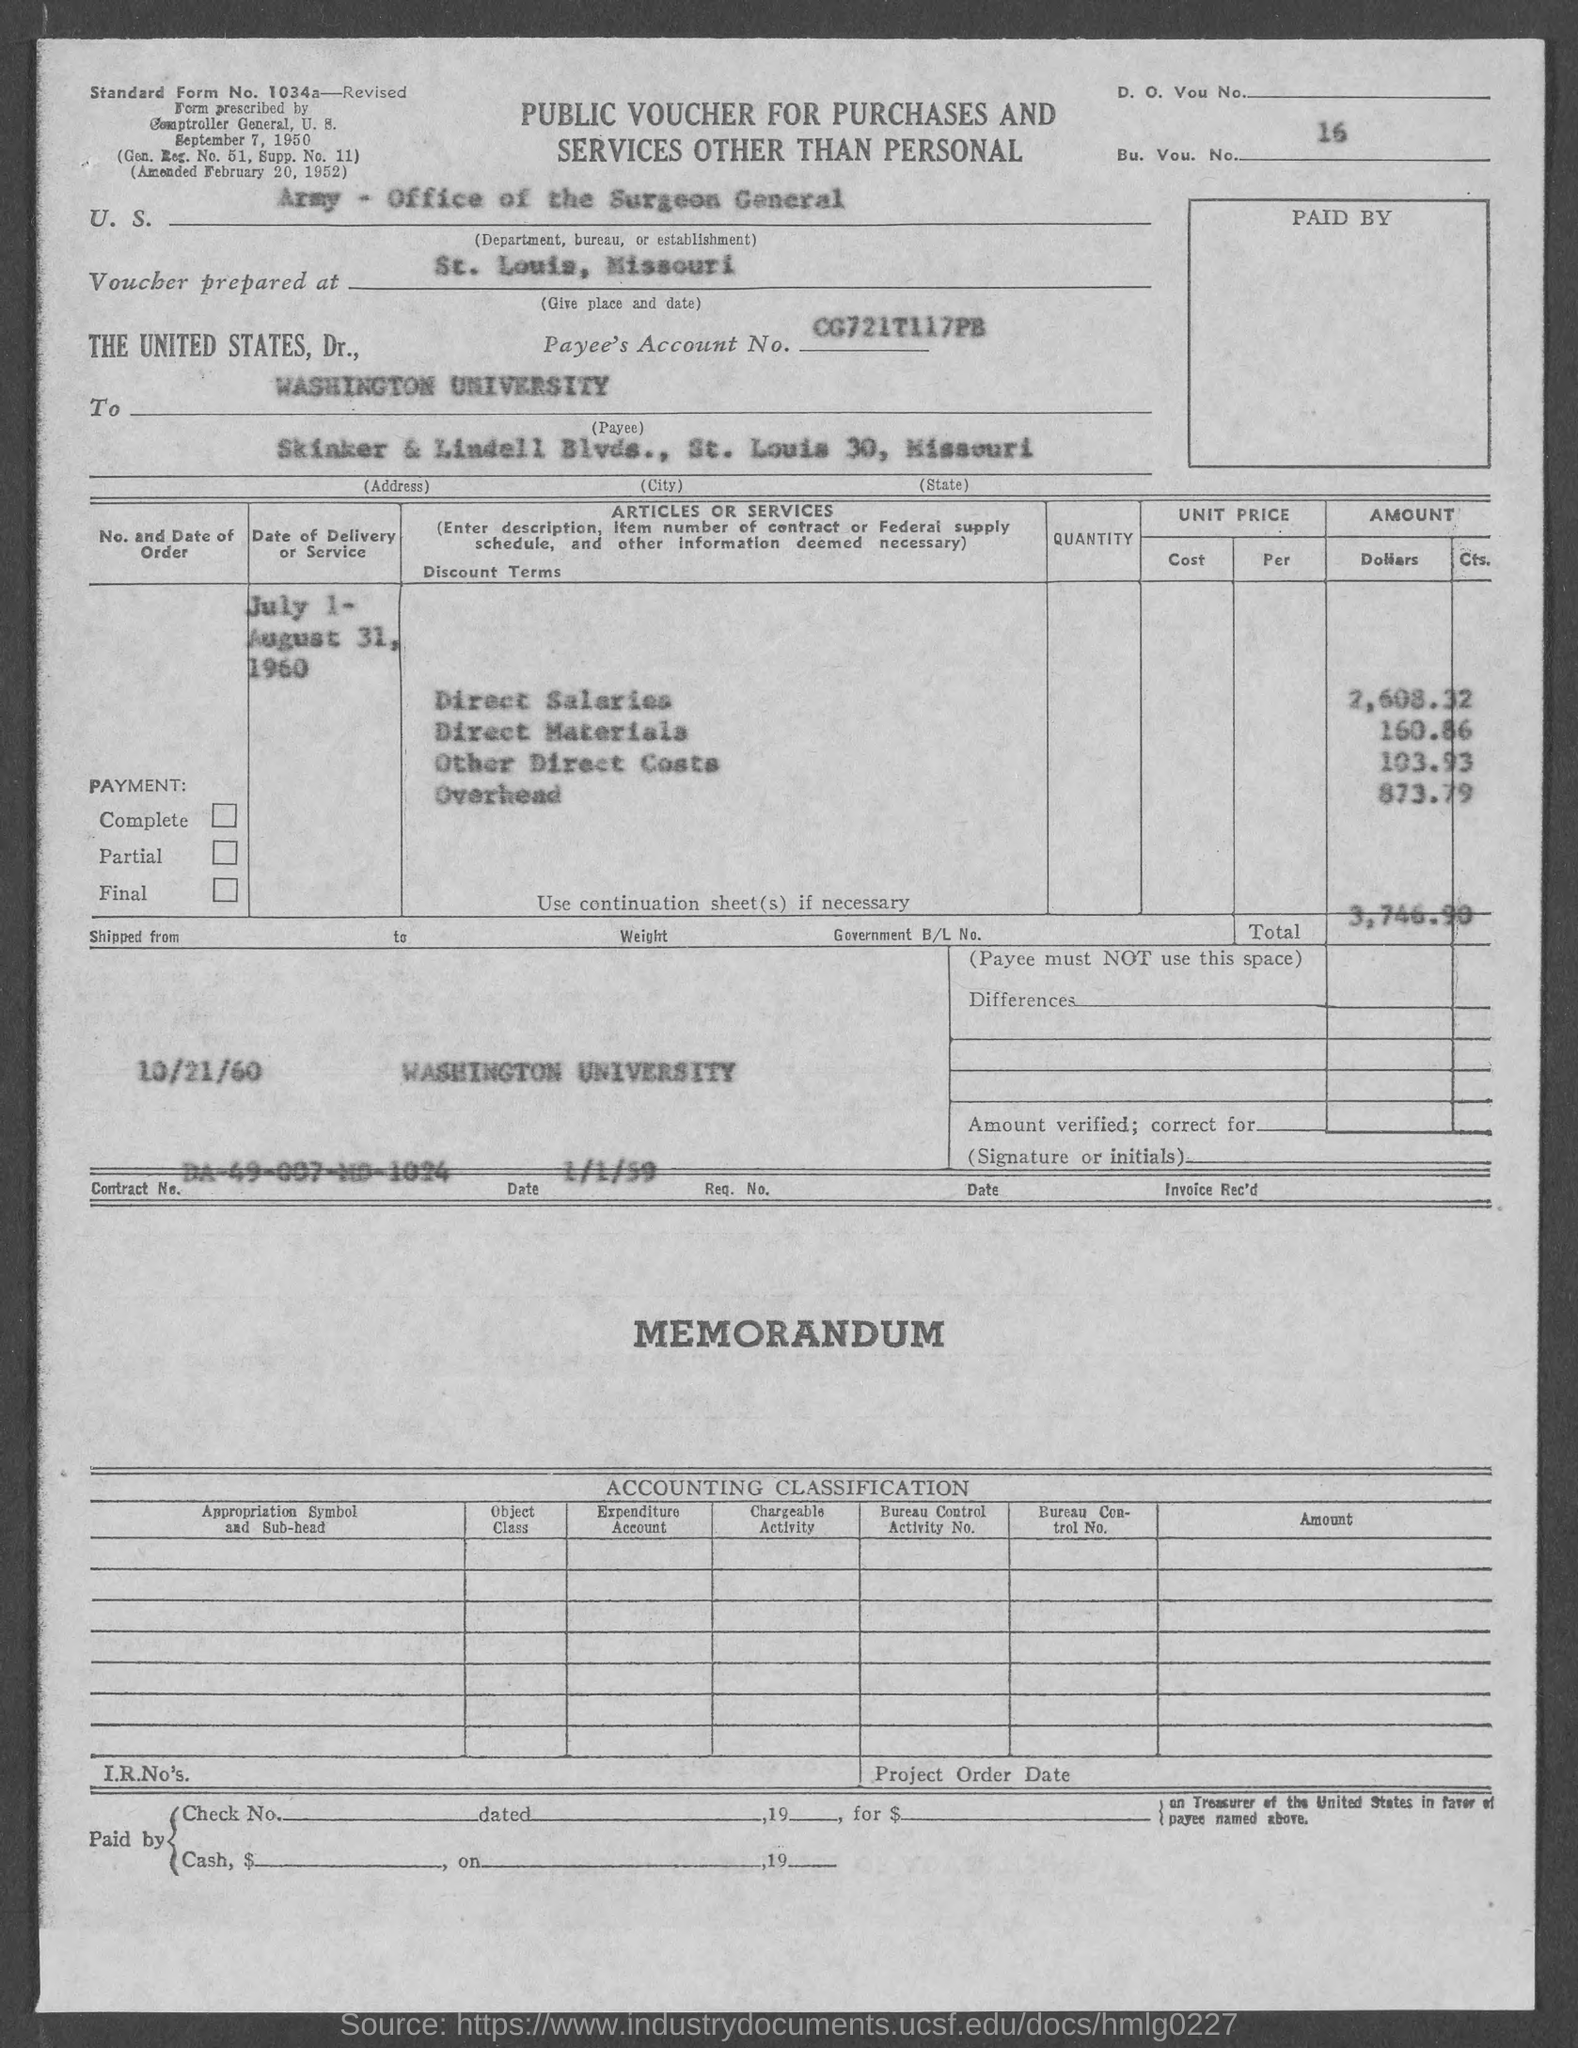What is the value of "Direct Salaries"?
Provide a succinct answer. 2,608.32. What is the value of "Direct Materials"?
Provide a succinct answer. 160.86. What is the value of " Other Direct Costs"?
Your response must be concise. 103.93. What is the value of "Overhead"?
Your answer should be compact. 873.79. What is the total cost?
Make the answer very short. 3,746.90. 